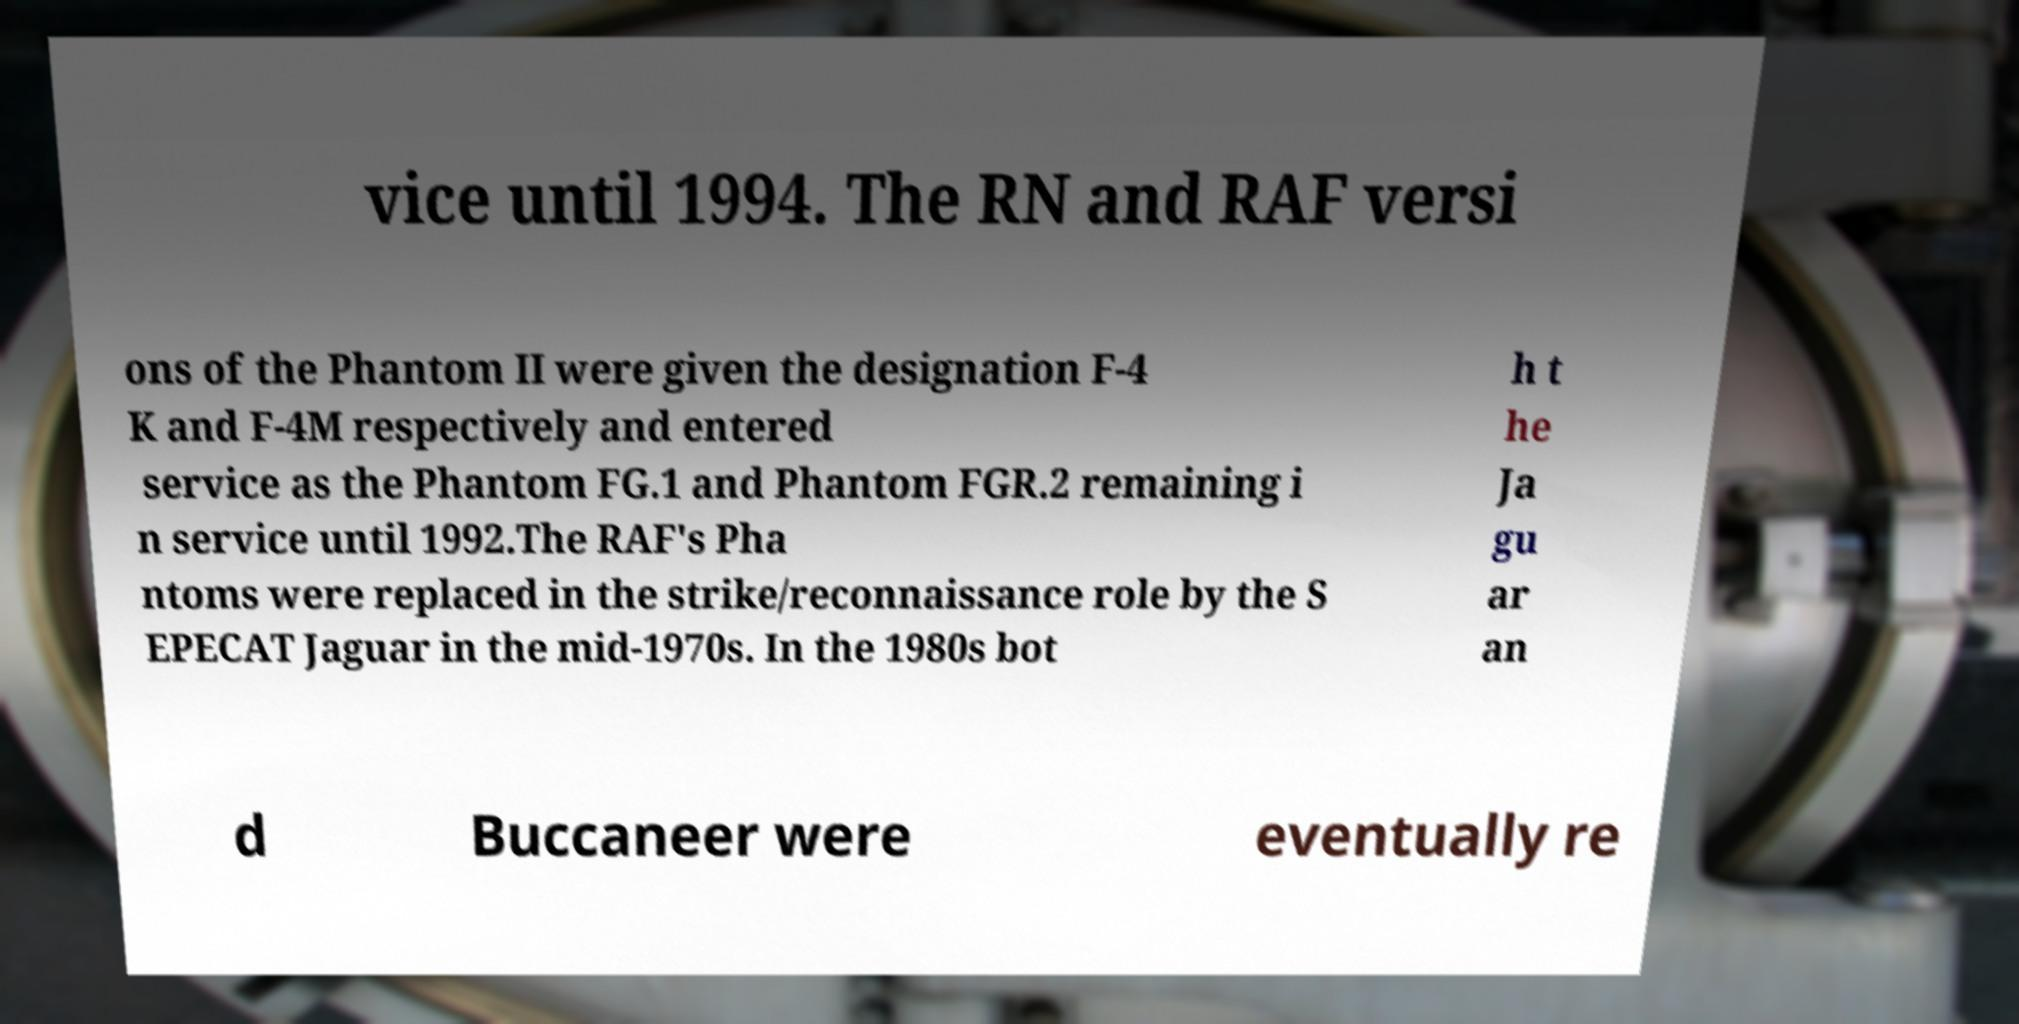What messages or text are displayed in this image? I need them in a readable, typed format. vice until 1994. The RN and RAF versi ons of the Phantom II were given the designation F-4 K and F-4M respectively and entered service as the Phantom FG.1 and Phantom FGR.2 remaining i n service until 1992.The RAF's Pha ntoms were replaced in the strike/reconnaissance role by the S EPECAT Jaguar in the mid-1970s. In the 1980s bot h t he Ja gu ar an d Buccaneer were eventually re 